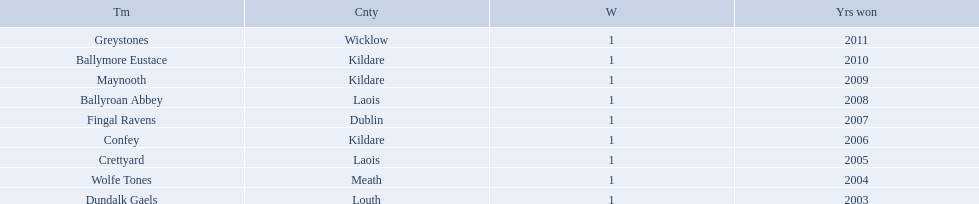What county is ballymore eustace from? Kildare. Would you be able to parse every entry in this table? {'header': ['Tm', 'Cnty', 'W', 'Yrs won'], 'rows': [['Greystones', 'Wicklow', '1', '2011'], ['Ballymore Eustace', 'Kildare', '1', '2010'], ['Maynooth', 'Kildare', '1', '2009'], ['Ballyroan Abbey', 'Laois', '1', '2008'], ['Fingal Ravens', 'Dublin', '1', '2007'], ['Confey', 'Kildare', '1', '2006'], ['Crettyard', 'Laois', '1', '2005'], ['Wolfe Tones', 'Meath', '1', '2004'], ['Dundalk Gaels', 'Louth', '1', '2003']]} Besides convey, which other team is from the same county? Maynooth. Where is ballymore eustace from? Kildare. What teams other than ballymore eustace is from kildare? Maynooth, Confey. Between maynooth and confey, which won in 2009? Maynooth. 